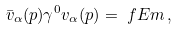<formula> <loc_0><loc_0><loc_500><loc_500>\bar { v } _ { \alpha } ( p ) \gamma ^ { 0 } v _ { \alpha } ( p ) & = \ f { E } { m } \, ,</formula> 